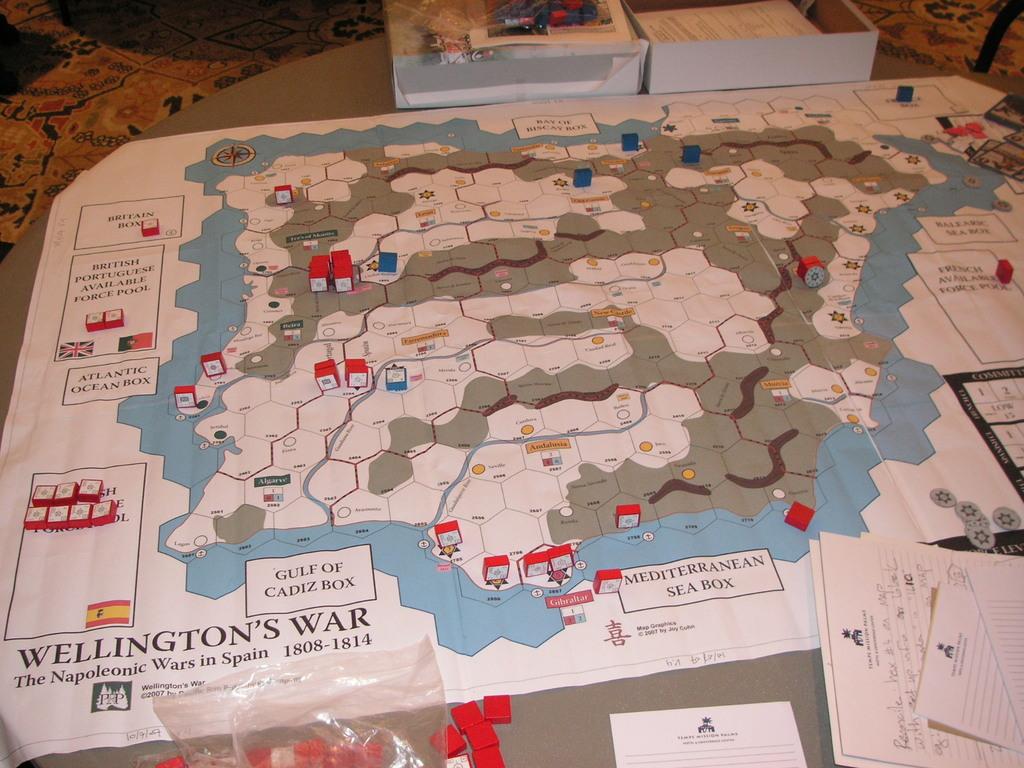What year does the map represent?
Ensure brevity in your answer.  1808-1814. Which sea's box is shown on the bottom of the map?
Your answer should be compact. Mediterranean. 